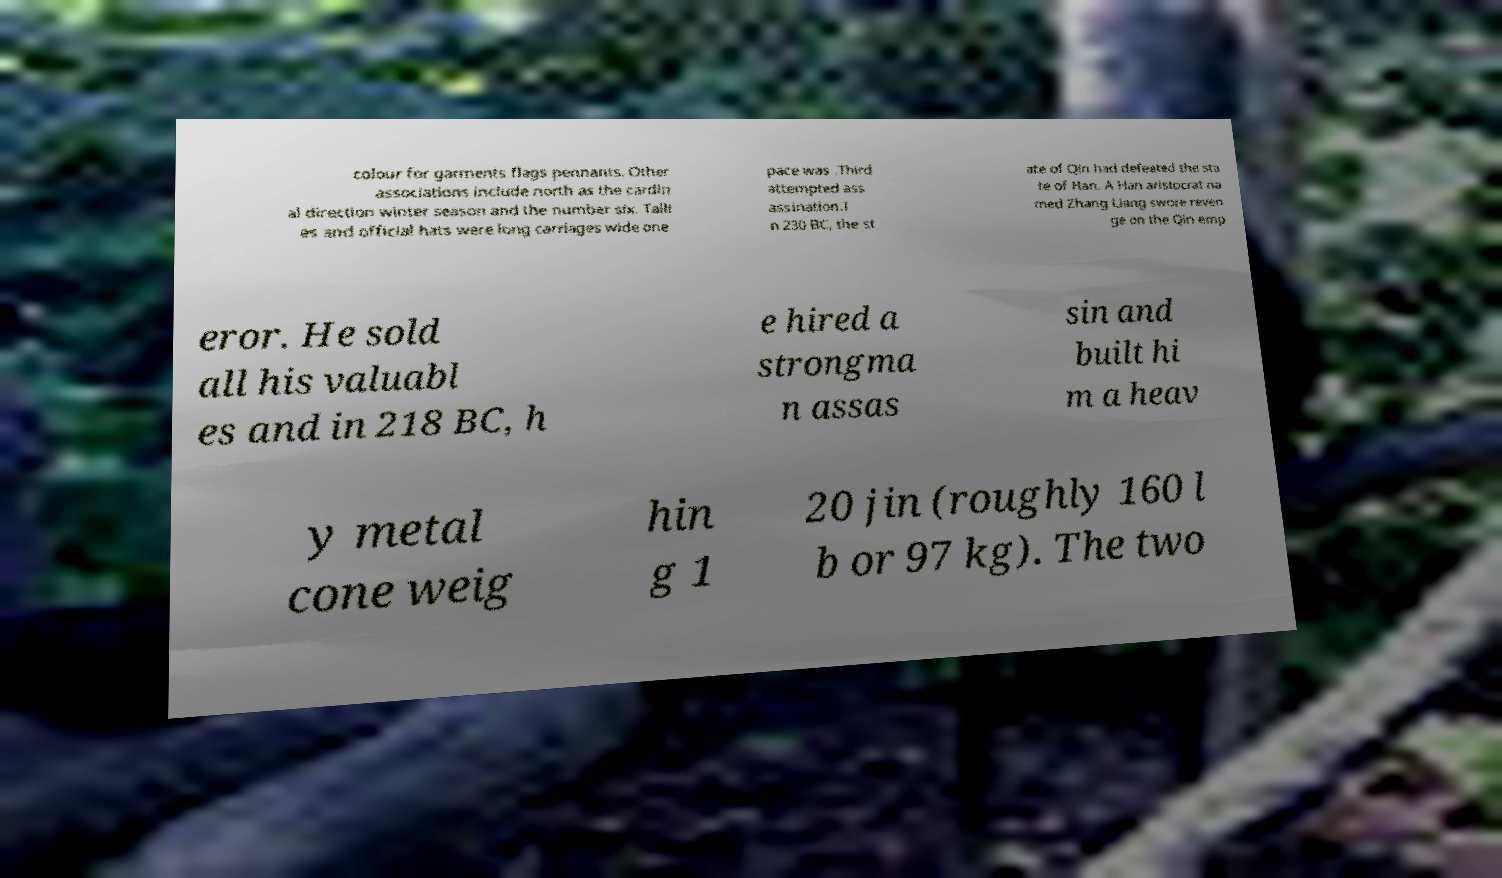Can you read and provide the text displayed in the image?This photo seems to have some interesting text. Can you extract and type it out for me? colour for garments flags pennants. Other associations include north as the cardin al direction winter season and the number six. Talli es and official hats were long carriages wide one pace was .Third attempted ass assination.I n 230 BC, the st ate of Qin had defeated the sta te of Han. A Han aristocrat na med Zhang Liang swore reven ge on the Qin emp eror. He sold all his valuabl es and in 218 BC, h e hired a strongma n assas sin and built hi m a heav y metal cone weig hin g 1 20 jin (roughly 160 l b or 97 kg). The two 